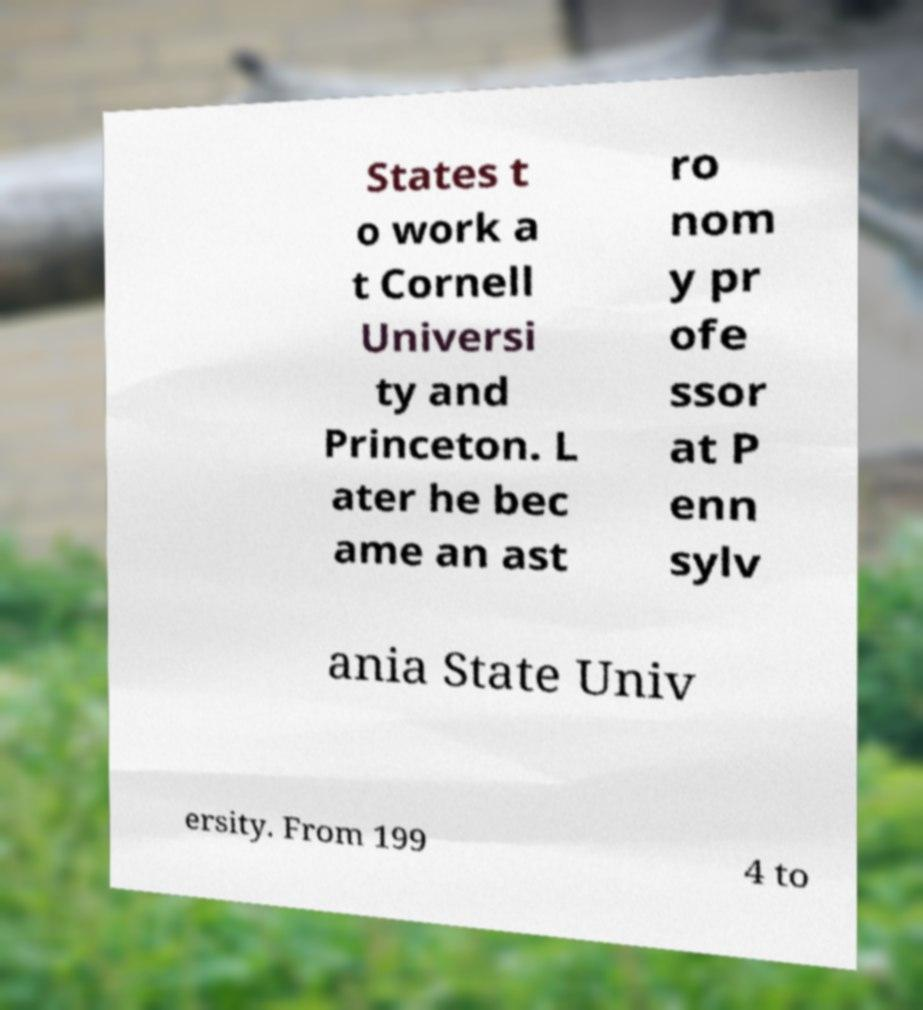I need the written content from this picture converted into text. Can you do that? States t o work a t Cornell Universi ty and Princeton. L ater he bec ame an ast ro nom y pr ofe ssor at P enn sylv ania State Univ ersity. From 199 4 to 